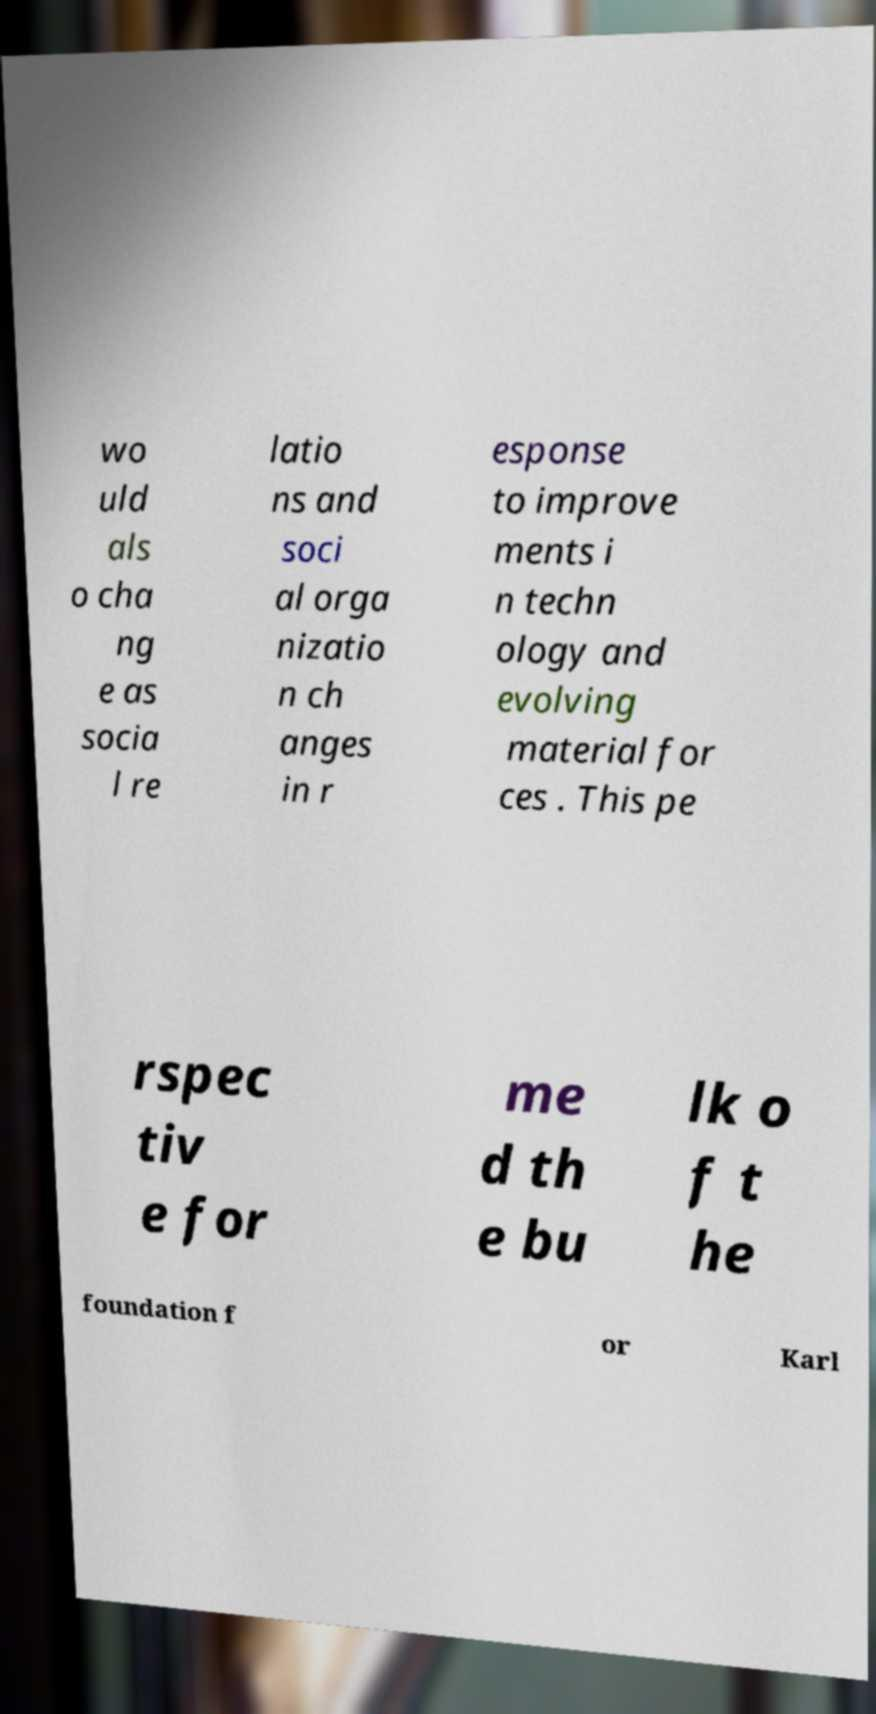For documentation purposes, I need the text within this image transcribed. Could you provide that? wo uld als o cha ng e as socia l re latio ns and soci al orga nizatio n ch anges in r esponse to improve ments i n techn ology and evolving material for ces . This pe rspec tiv e for me d th e bu lk o f t he foundation f or Karl 